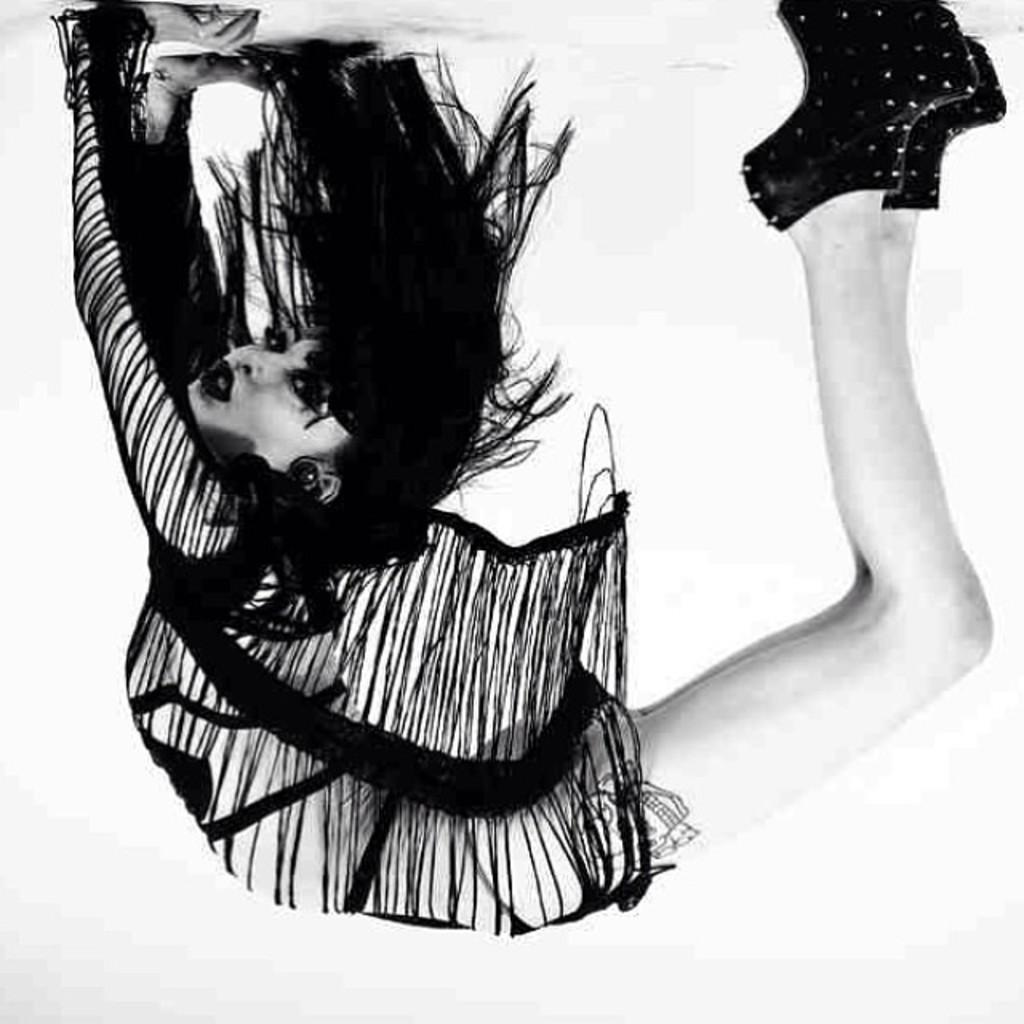What is the main subject of the image? There is a person in the image. What is the person doing in the image? The person is bending. What is the color scheme of the image? The image is black and white. What type of leaf can be seen falling in the image? There is no leaf present in the image; it is a black and white image of a person bending. 